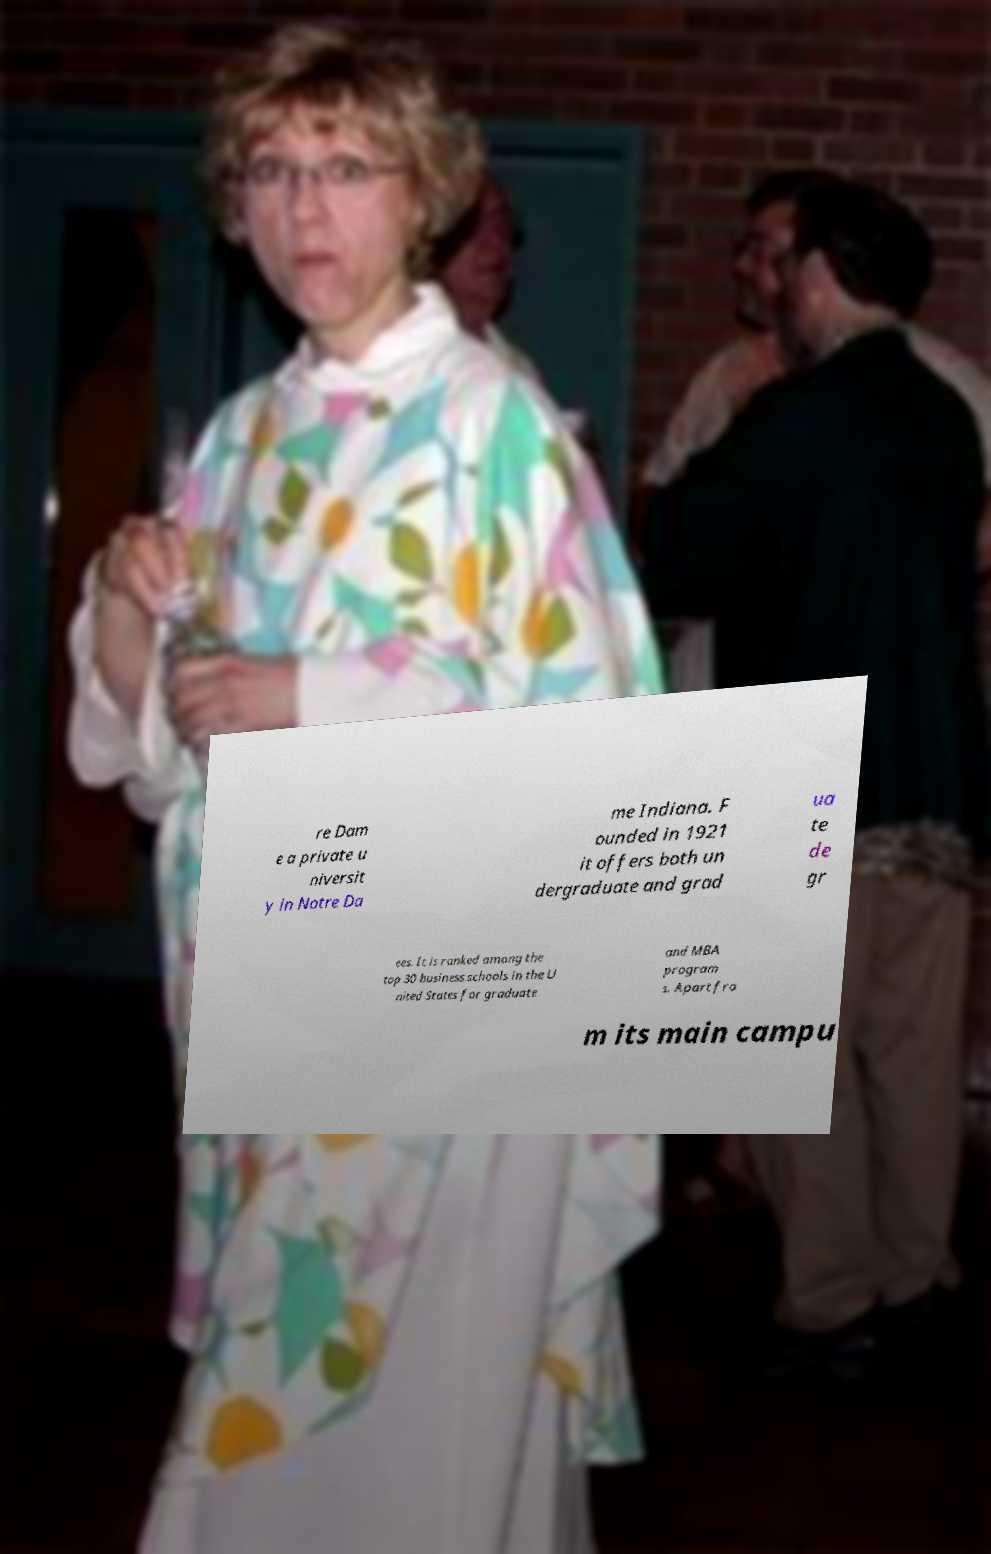Please read and relay the text visible in this image. What does it say? re Dam e a private u niversit y in Notre Da me Indiana. F ounded in 1921 it offers both un dergraduate and grad ua te de gr ees. It is ranked among the top 30 business schools in the U nited States for graduate and MBA program s. Apart fro m its main campu 